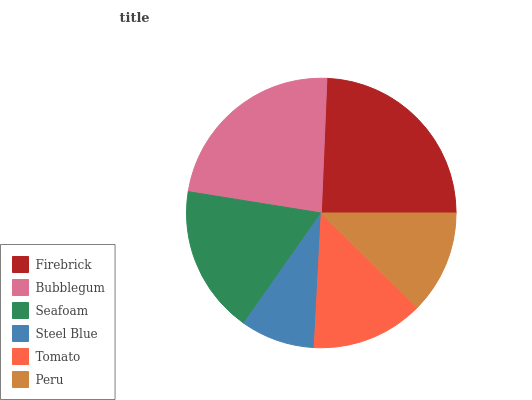Is Steel Blue the minimum?
Answer yes or no. Yes. Is Firebrick the maximum?
Answer yes or no. Yes. Is Bubblegum the minimum?
Answer yes or no. No. Is Bubblegum the maximum?
Answer yes or no. No. Is Firebrick greater than Bubblegum?
Answer yes or no. Yes. Is Bubblegum less than Firebrick?
Answer yes or no. Yes. Is Bubblegum greater than Firebrick?
Answer yes or no. No. Is Firebrick less than Bubblegum?
Answer yes or no. No. Is Seafoam the high median?
Answer yes or no. Yes. Is Tomato the low median?
Answer yes or no. Yes. Is Bubblegum the high median?
Answer yes or no. No. Is Bubblegum the low median?
Answer yes or no. No. 